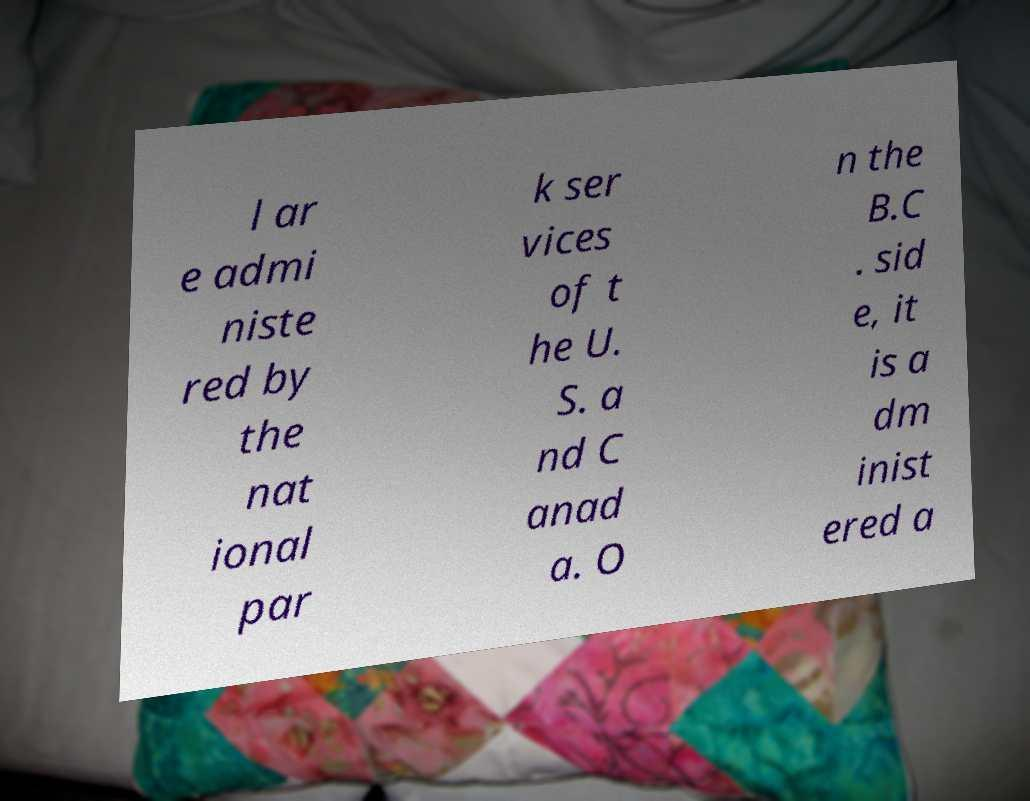Could you assist in decoding the text presented in this image and type it out clearly? l ar e admi niste red by the nat ional par k ser vices of t he U. S. a nd C anad a. O n the B.C . sid e, it is a dm inist ered a 